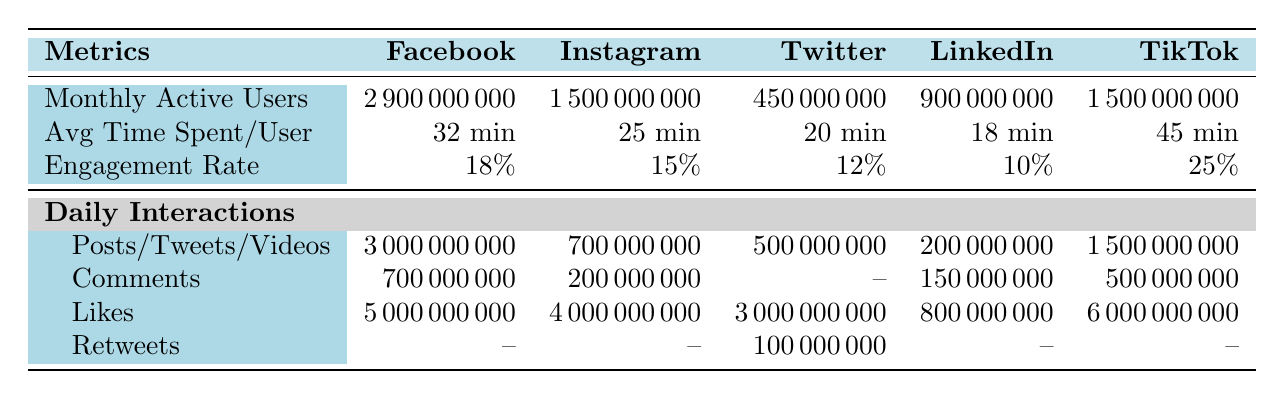What is the engagement rate of TikTok? The engagement rate for TikTok is listed under the Engagement Rate row in the TikTok column of the table, which shows 25%.
Answer: 25% How many monthly active users does LinkedIn have? The number of monthly active users for LinkedIn can be found in the Monthly Active Users row in the LinkedIn column, which indicates 900 million.
Answer: 900000000 Which application has the highest average time spent per user? By comparing the Avg Time Spent/User row across all applications, TikTok has the highest value at 45 minutes.
Answer: TikTok What is the total number of daily posts across all applications? To find the total daily posts, add the number of Posts from the Daily Interactions rows: 3 billion (Facebook) + 700 million (Instagram) + 500 million (Twitter) + 200 million (LinkedIn) + 1.5 billion (TikTok). Thus, total = 3,000,000,000 + 700,000,000 + 500,000,000 + 200,000,000 + 1,500,000,000 = 6.9 billion.
Answer: 6900000000 Does Twitter have more daily likes than LinkedIn? Comparing the Likes in the Daily Interactions section, Twitter has 3 billion likes while LinkedIn has 800 million likes. Since 3 billion is greater than 800 million, the statement is true.
Answer: Yes Which app has the lowest engagement rate? The engagement rates for the applications are 18% (Facebook), 15% (Instagram), 12% (Twitter), 10% (LinkedIn), and 25% (TikTok). Therefore, LinkedIn has the lowest engagement rate at 10%.
Answer: LinkedIn How many more daily comments does Facebook have compared to Instagram? The table shows Facebook with 700 million comments and Instagram with 200 million comments. The difference is 700 million - 200 million = 500 million.
Answer: 500000000 Which app has the least number of monthly active users? By comparing the Monthly Active Users row for all applications, Twitter has 450 million, which is the least.
Answer: Twitter How many total daily interactions (sum of posts, comments, and likes) does Instagram have? To calculate the total daily interactions for Instagram, add the values in the Daily Interactions section: 700 million (posts) + 200 million (comments) + 4 billion (likes) = 700,000,000 + 200,000,000 + 4,000,000,000 = 4.9 billion.
Answer: 4900000000 